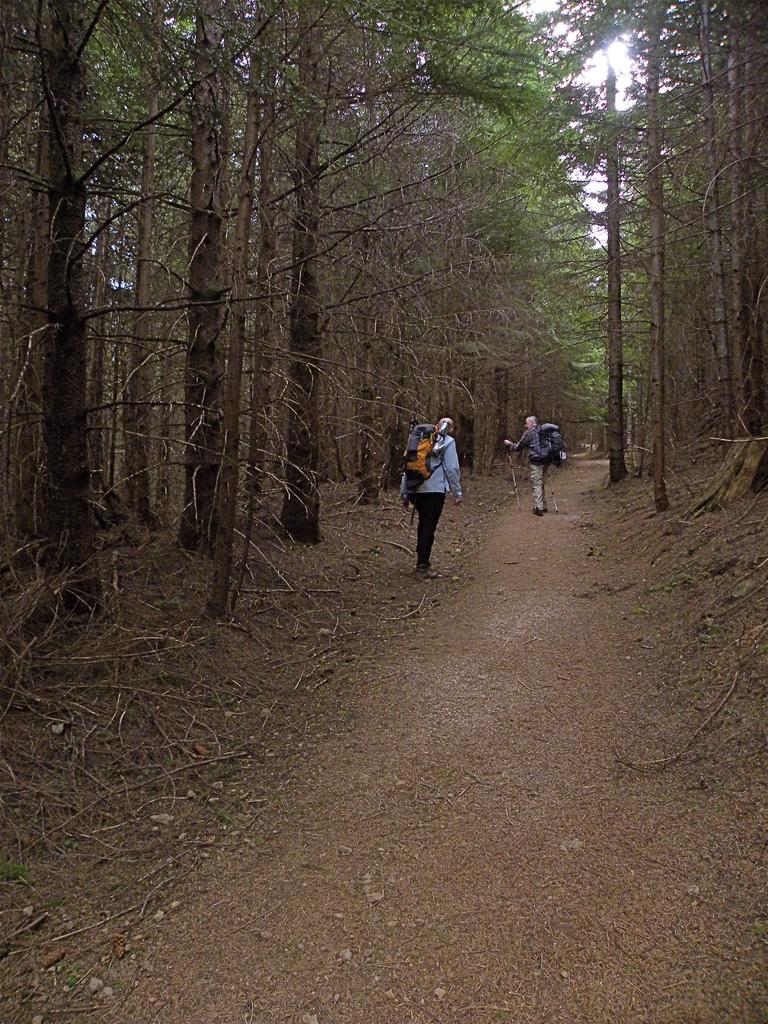How many people are in the image? There are two persons standing in the image. What can be seen in the background of the image? Trees are visible in the background of the image. What is visible at the top of the image? The sky is visible at the top of the image. What type of objects are present at the bottom of the image? Tree branches and stones are visible at the bottom of the image. What type of silk fabric is draped over the tree branches in the image? There is no silk fabric present in the image; only tree branches and stones are visible at the bottom. 